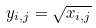<formula> <loc_0><loc_0><loc_500><loc_500>y _ { i , j } = \sqrt { x _ { i , j } }</formula> 